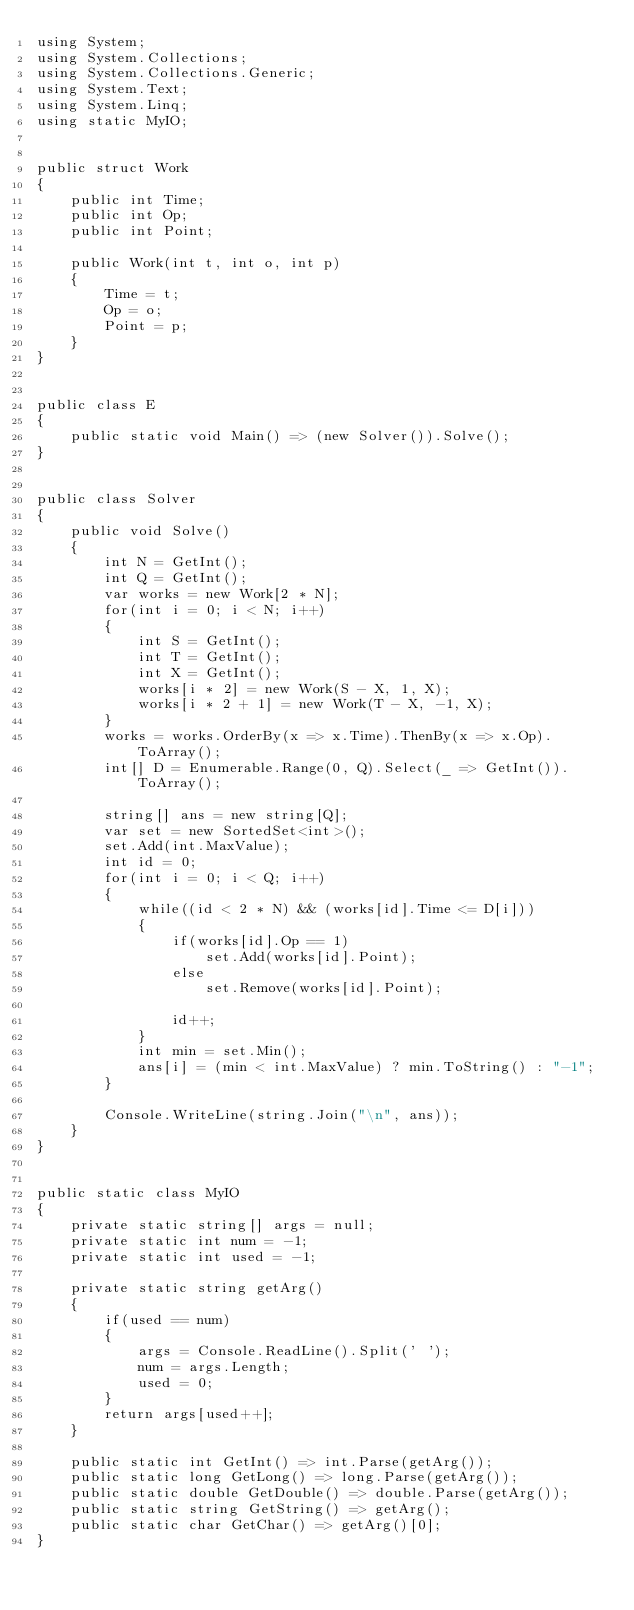<code> <loc_0><loc_0><loc_500><loc_500><_C#_>using System;
using System.Collections;
using System.Collections.Generic;
using System.Text;
using System.Linq;
using static MyIO;


public struct Work
{
	public int Time;
	public int Op;
	public int Point;

	public Work(int t, int o, int p)
	{
		Time = t;
		Op = o;
		Point = p;
	}
}


public class E
{
	public static void Main() => (new Solver()).Solve();
}


public class Solver
{
	public void Solve()
	{
		int N = GetInt();
		int Q = GetInt();
		var works = new Work[2 * N];
		for(int i = 0; i < N; i++)
		{
			int S = GetInt();
			int T = GetInt();
			int X = GetInt();
			works[i * 2] = new Work(S - X, 1, X);
			works[i * 2 + 1] = new Work(T - X, -1, X);
		}
		works = works.OrderBy(x => x.Time).ThenBy(x => x.Op).ToArray();
		int[] D = Enumerable.Range(0, Q).Select(_ => GetInt()).ToArray();

		string[] ans = new string[Q];
		var set = new SortedSet<int>();
		set.Add(int.MaxValue);
		int id = 0;
		for(int i = 0; i < Q; i++)
		{
			while((id < 2 * N) && (works[id].Time <= D[i]))
			{
				if(works[id].Op == 1)
					set.Add(works[id].Point);
				else
					set.Remove(works[id].Point);

				id++;
			}
			int min = set.Min();
			ans[i] = (min < int.MaxValue) ? min.ToString() : "-1";
		}

		Console.WriteLine(string.Join("\n", ans));
	}
}


public static class MyIO
{
	private static string[] args = null;
	private static int num = -1;
	private static int used = -1;

	private static string getArg()
	{
		if(used == num)
		{
			args = Console.ReadLine().Split(' ');
			num = args.Length;
			used = 0;
		}
		return args[used++];
	}

	public static int GetInt() => int.Parse(getArg());
	public static long GetLong() => long.Parse(getArg());
	public static double GetDouble() => double.Parse(getArg());
	public static string GetString() => getArg();
	public static char GetChar() => getArg()[0];
}
</code> 